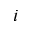Convert formula to latex. <formula><loc_0><loc_0><loc_500><loc_500>i</formula> 